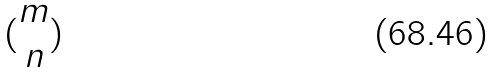<formula> <loc_0><loc_0><loc_500><loc_500>( \begin{matrix} m \\ n \end{matrix} )</formula> 